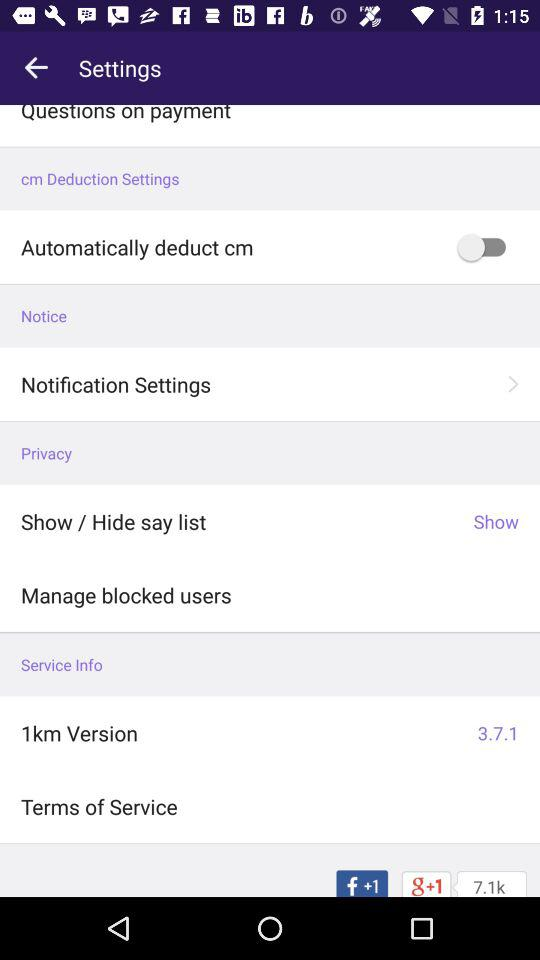What features does the '1km' app provide in its latest update? The latest update of the '1km' app might include enhancements like improved user interface, faster performance, or new tools for better user engagement. However, for detailed features, checking the update notes in the app's store page or within the app itself under 'What's New' section is recommended. 